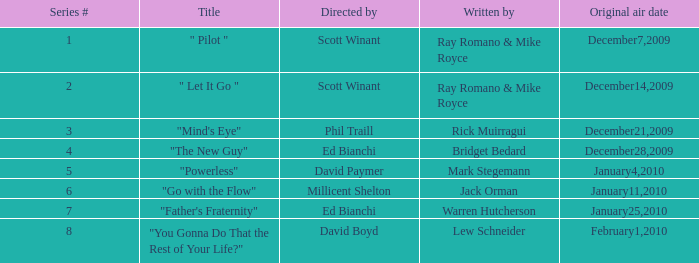When was the episode "you gonna do that the rest of your life?" broadcasted? February1,2010. 